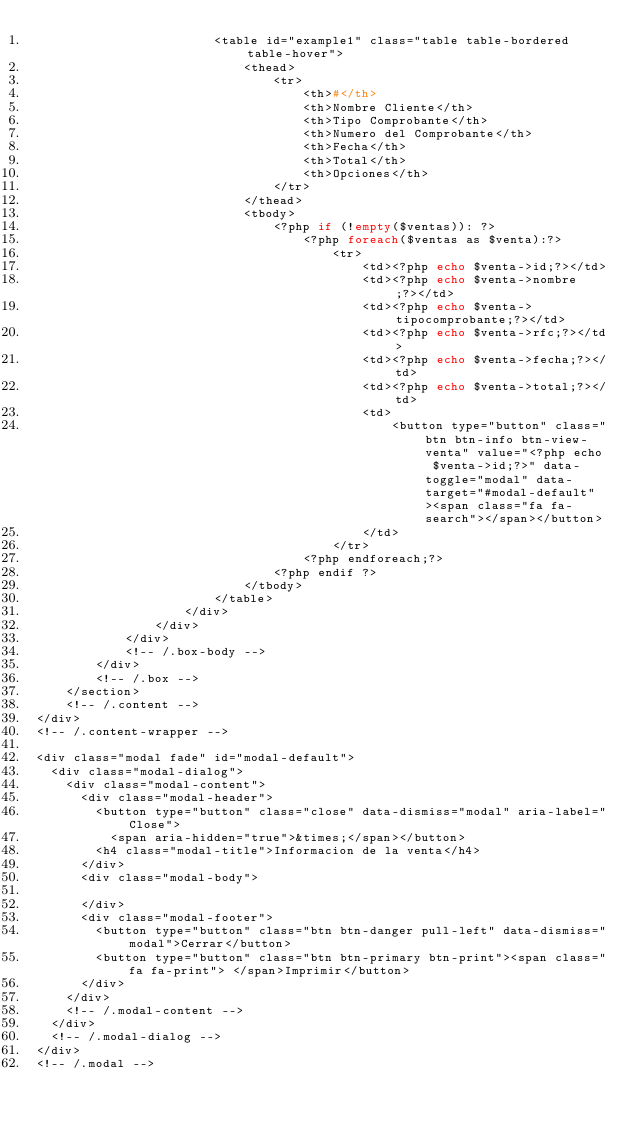Convert code to text. <code><loc_0><loc_0><loc_500><loc_500><_PHP_>                        <table id="example1" class="table table-bordered table-hover">
                            <thead>
                                <tr>
                                    <th>#</th>
                                    <th>Nombre Cliente</th>
                                    <th>Tipo Comprobante</th>
                                    <th>Numero del Comprobante</th>
                                    <th>Fecha</th>
                                    <th>Total</th>
                                    <th>Opciones</th>
                                </tr>
                            </thead>
                            <tbody>
                                <?php if (!empty($ventas)): ?>
                                    <?php foreach($ventas as $venta):?>
                                        <tr>
                                            <td><?php echo $venta->id;?></td>
                                            <td><?php echo $venta->nombre;?></td>
                                            <td><?php echo $venta->tipocomprobante;?></td>
                                            <td><?php echo $venta->rfc;?></td>
                                            <td><?php echo $venta->fecha;?></td>
                                            <td><?php echo $venta->total;?></td>
                                            <td>
                                                <button type="button" class="btn btn-info btn-view-venta" value="<?php echo $venta->id;?>" data-toggle="modal" data-target="#modal-default"><span class="fa fa-search"></span></button>
                                            </td>
                                        </tr>
                                    <?php endforeach;?>
                                <?php endif ?>
                            </tbody>
                        </table>
                    </div>
                </div>
            </div>
            <!-- /.box-body -->
        </div>
        <!-- /.box -->
    </section>
    <!-- /.content -->
</div>
<!-- /.content-wrapper -->

<div class="modal fade" id="modal-default">
  <div class="modal-dialog">
    <div class="modal-content">
      <div class="modal-header">
        <button type="button" class="close" data-dismiss="modal" aria-label="Close">
          <span aria-hidden="true">&times;</span></button>
        <h4 class="modal-title">Informacion de la venta</h4>
      </div>
      <div class="modal-body">
        
      </div>
      <div class="modal-footer">
        <button type="button" class="btn btn-danger pull-left" data-dismiss="modal">Cerrar</button>
        <button type="button" class="btn btn-primary btn-print"><span class="fa fa-print"> </span>Imprimir</button>
      </div>
    </div>
    <!-- /.modal-content -->
  </div>
  <!-- /.modal-dialog -->
</div>
<!-- /.modal -->
</code> 